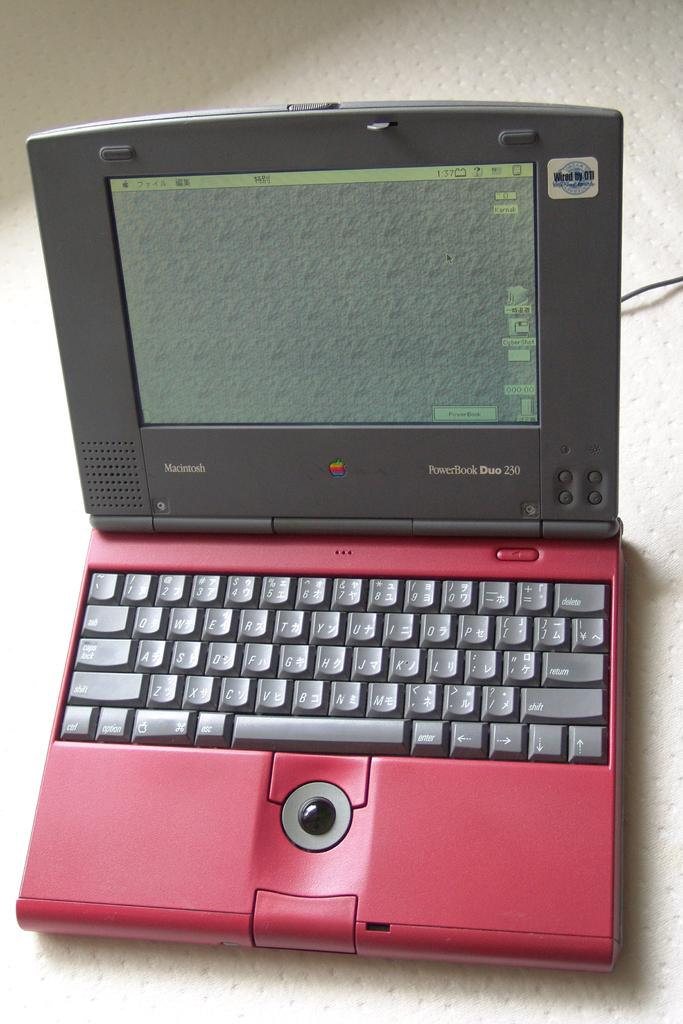<image>
Summarize the visual content of the image. The laptop has the words Macintosh on the side 